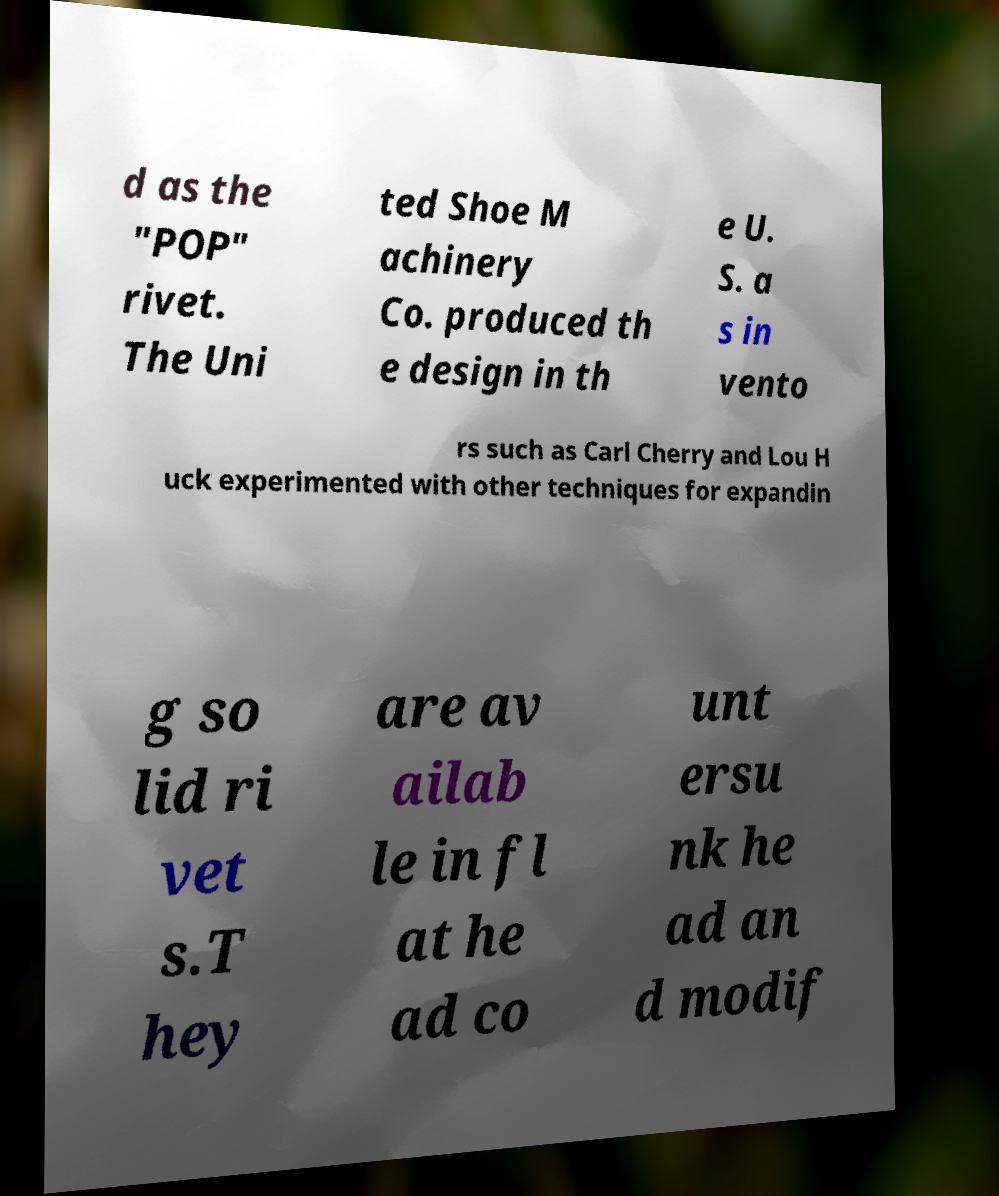For documentation purposes, I need the text within this image transcribed. Could you provide that? d as the "POP" rivet. The Uni ted Shoe M achinery Co. produced th e design in th e U. S. a s in vento rs such as Carl Cherry and Lou H uck experimented with other techniques for expandin g so lid ri vet s.T hey are av ailab le in fl at he ad co unt ersu nk he ad an d modif 